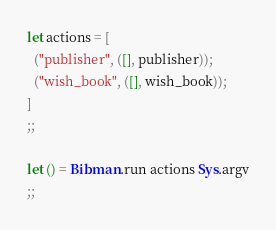<code> <loc_0><loc_0><loc_500><loc_500><_OCaml_>
let actions = [
  ("publisher", ([], publisher));
  ("wish_book", ([], wish_book));
]
;;

let () = Bibman.run actions Sys.argv
;;
</code> 